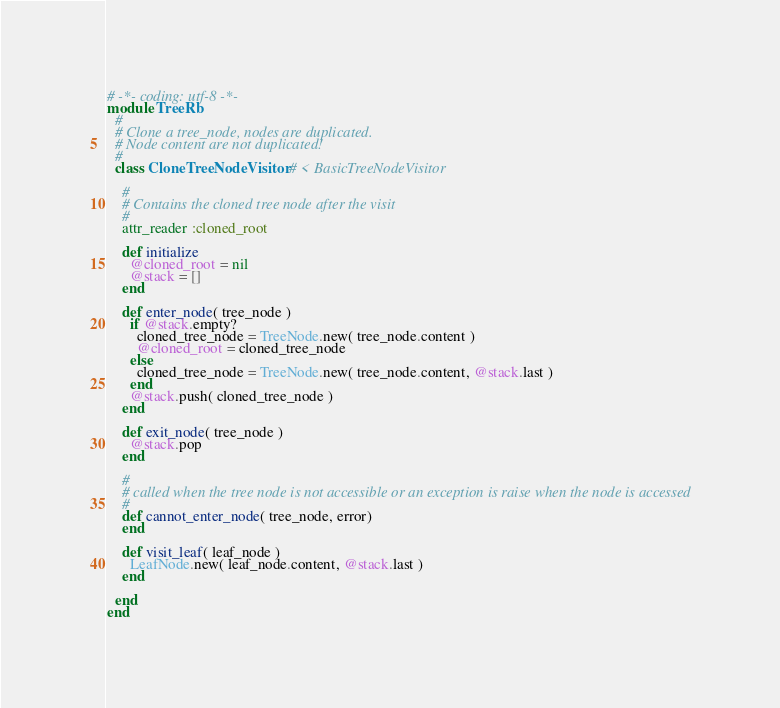Convert code to text. <code><loc_0><loc_0><loc_500><loc_500><_Ruby_># -*- coding: utf-8 -*-
module TreeRb
  #
  # Clone a tree_node, nodes are duplicated.
  # Node content are not duplicated!
  #
  class CloneTreeNodeVisitor # < BasicTreeNodeVisitor

    #
    # Contains the cloned tree node after the visit
    #
    attr_reader :cloned_root

    def initialize
      @cloned_root = nil
      @stack = []
    end

    def enter_node( tree_node )
      if @stack.empty?
        cloned_tree_node = TreeNode.new( tree_node.content )
        @cloned_root = cloned_tree_node
      else
        cloned_tree_node = TreeNode.new( tree_node.content, @stack.last )
      end
      @stack.push( cloned_tree_node )
    end

    def exit_node( tree_node )
      @stack.pop
    end

    #
    # called when the tree node is not accessible or an exception is raise when the node is accessed
    #
    def cannot_enter_node( tree_node, error)
    end

    def visit_leaf( leaf_node )
      LeafNode.new( leaf_node.content, @stack.last )
    end

  end
end
</code> 